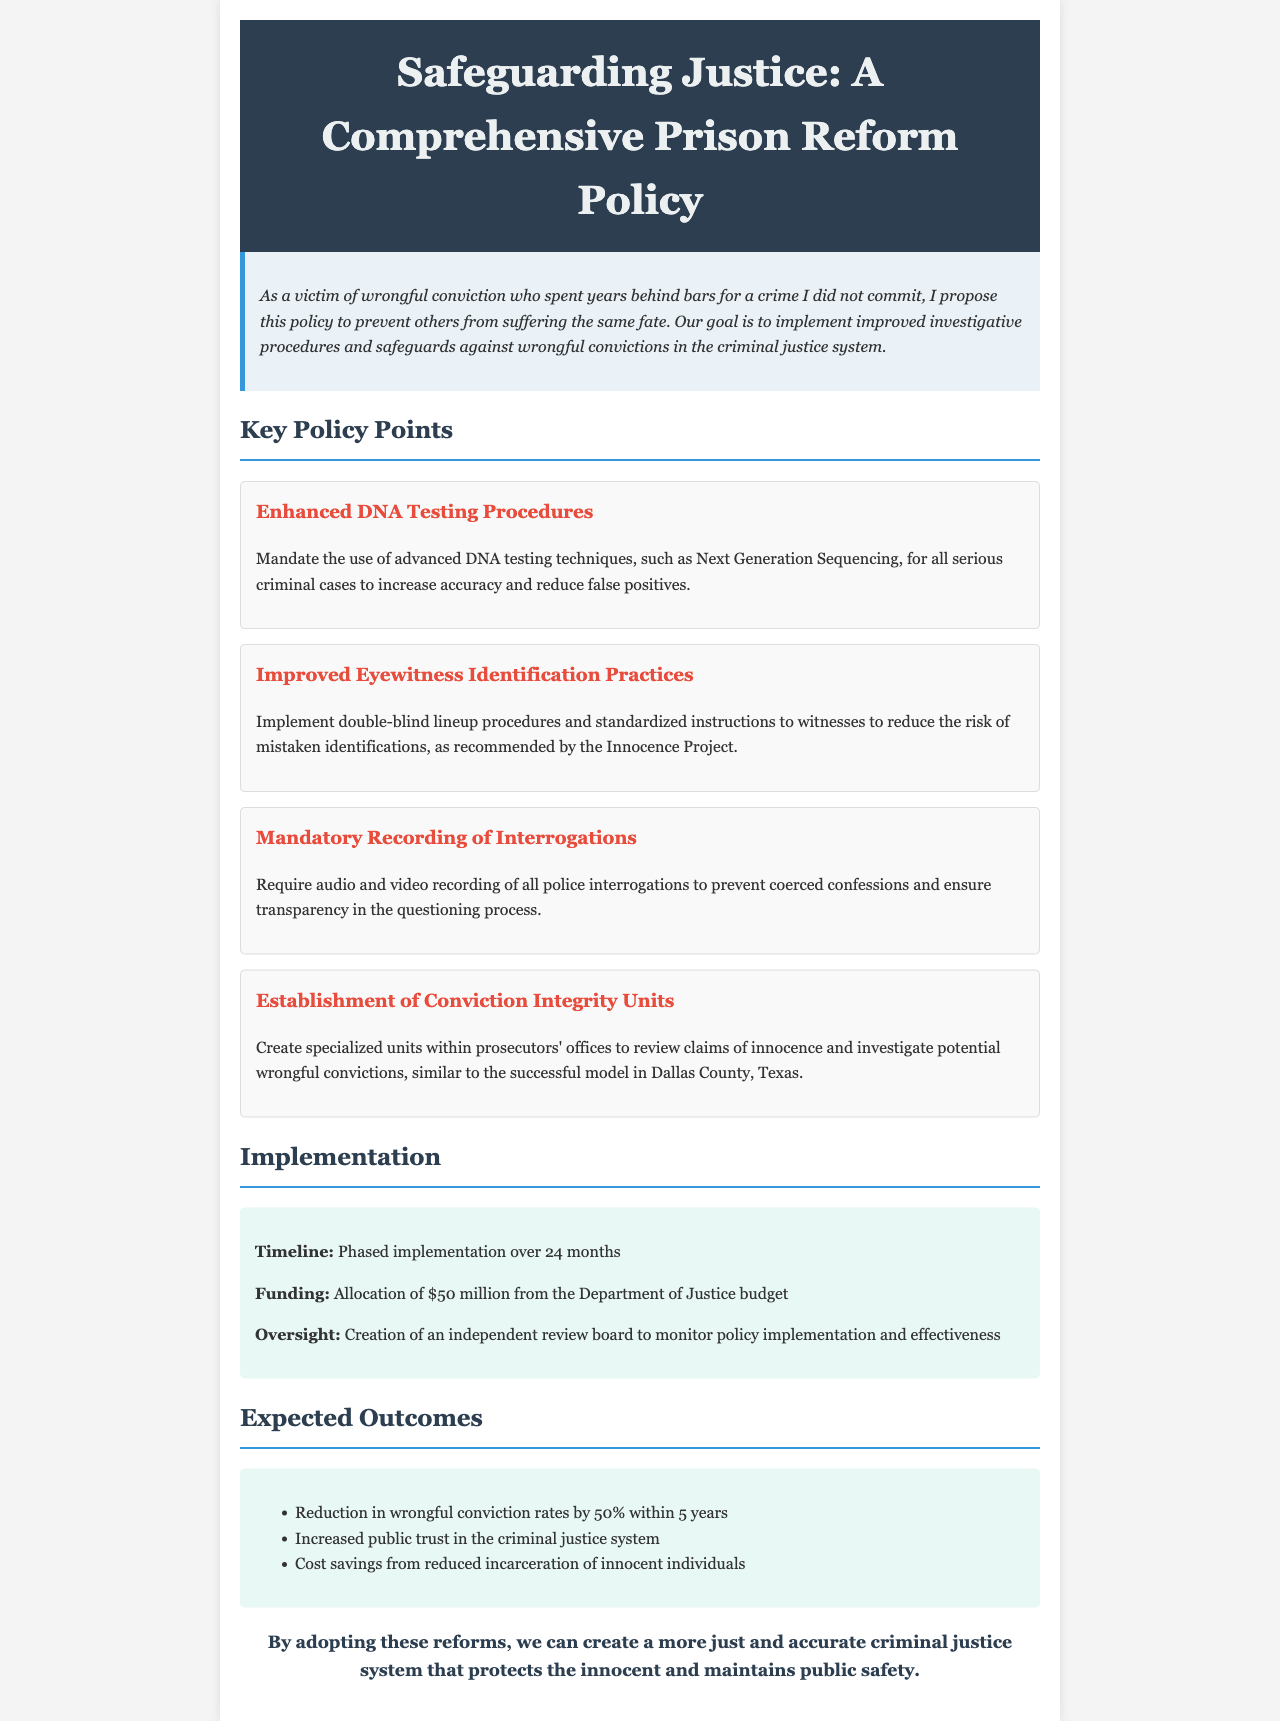What is the title of the policy document? The title is stated in the header of the document.
Answer: Safeguarding Justice: A Comprehensive Prison Reform Policy What advanced DNA testing technique is mandated? The document specifies the DNA testing technique to be used.
Answer: Next Generation Sequencing How many months is the implementation timeline? The timeline for phased implementation is provided in the implementation section.
Answer: 24 months What is the funding amount allocated for this policy? The funding amount is stated in the implementation section of the document.
Answer: $50 million What is the expected reduction in wrongful conviction rates? The expected outcome regarding wrongful conviction rates is mentioned in the outcomes section.
Answer: 50% What type of units will be established according to this policy? The document discusses the creation concerning specific units.
Answer: Conviction Integrity Units What is required during police interrogations? The document outlines a requirement regarding police interrogations.
Answer: Mandatory recording What does the independent review board monitor? The purpose of the independent review board is specified in the implementation section.
Answer: Policy implementation and effectiveness What is one expected outcome of this policy? The document lists various expected outcomes in the outcomes section.
Answer: Increased public trust in the criminal justice system 